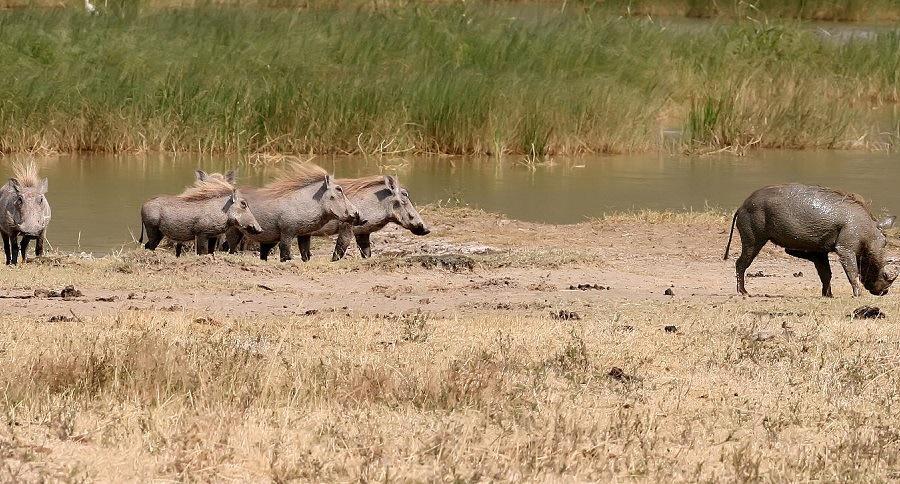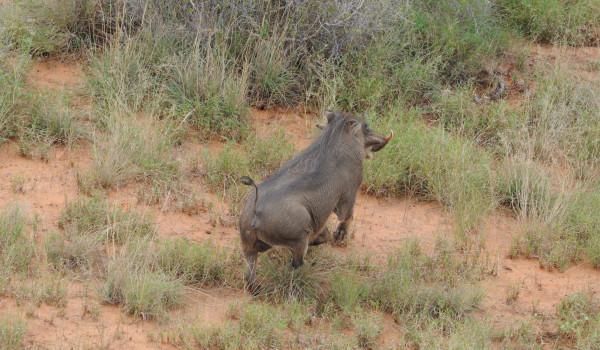The first image is the image on the left, the second image is the image on the right. For the images displayed, is the sentence "there is exactly one human in the image on the left" factually correct? Answer yes or no. No. The first image is the image on the left, the second image is the image on the right. For the images displayed, is the sentence "The image on the left shows a hunter wearing a hat and posing with his prey." factually correct? Answer yes or no. No. 